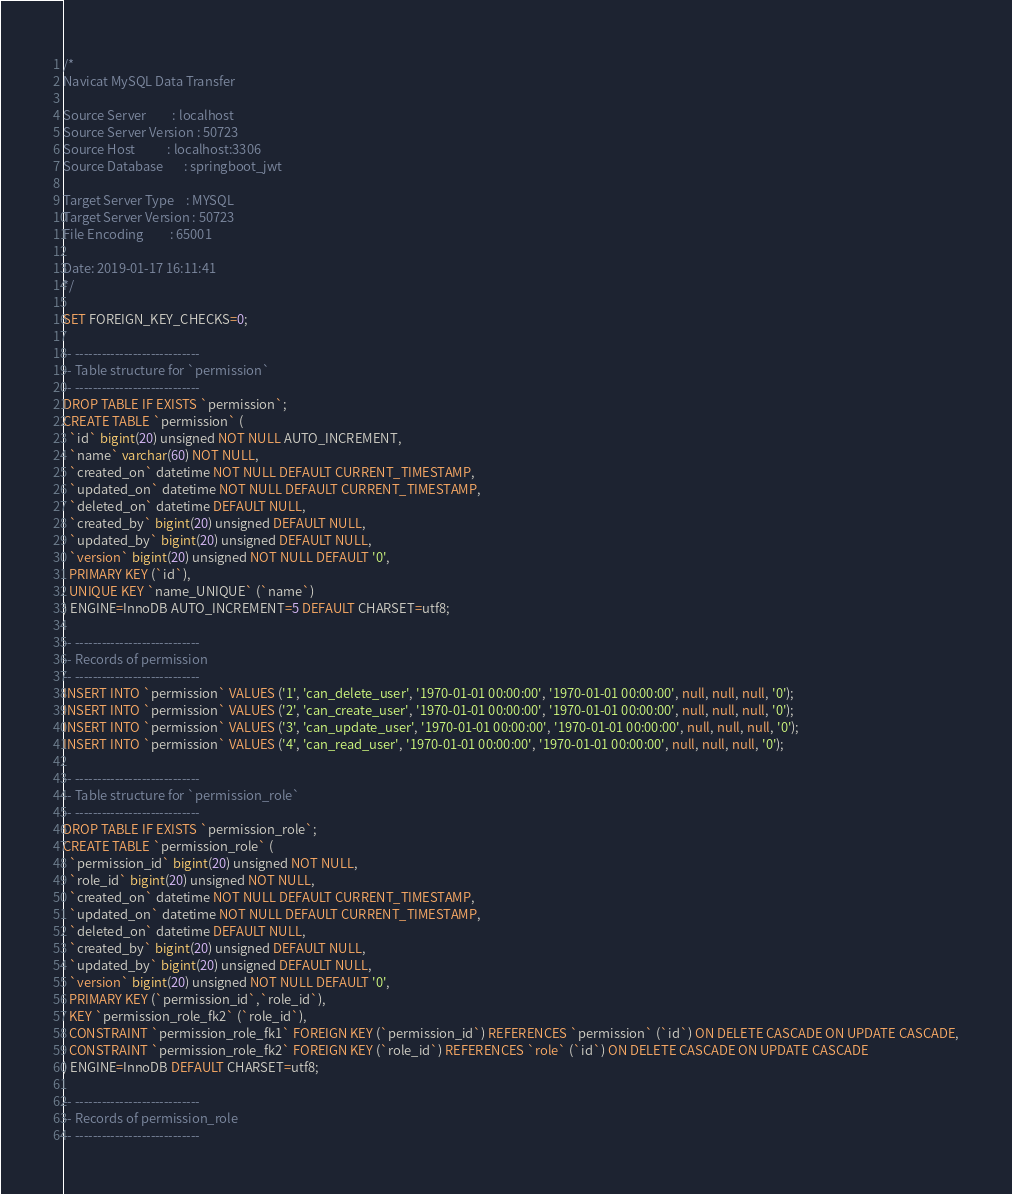Convert code to text. <code><loc_0><loc_0><loc_500><loc_500><_SQL_>/*
Navicat MySQL Data Transfer

Source Server         : localhost
Source Server Version : 50723
Source Host           : localhost:3306
Source Database       : springboot_jwt

Target Server Type    : MYSQL
Target Server Version : 50723
File Encoding         : 65001

Date: 2019-01-17 16:11:41
*/

SET FOREIGN_KEY_CHECKS=0;

-- ----------------------------
-- Table structure for `permission`
-- ----------------------------
DROP TABLE IF EXISTS `permission`;
CREATE TABLE `permission` (
  `id` bigint(20) unsigned NOT NULL AUTO_INCREMENT,
  `name` varchar(60) NOT NULL,
  `created_on` datetime NOT NULL DEFAULT CURRENT_TIMESTAMP,
  `updated_on` datetime NOT NULL DEFAULT CURRENT_TIMESTAMP,
  `deleted_on` datetime DEFAULT NULL,
  `created_by` bigint(20) unsigned DEFAULT NULL,
  `updated_by` bigint(20) unsigned DEFAULT NULL,
  `version` bigint(20) unsigned NOT NULL DEFAULT '0',
  PRIMARY KEY (`id`),
  UNIQUE KEY `name_UNIQUE` (`name`)
) ENGINE=InnoDB AUTO_INCREMENT=5 DEFAULT CHARSET=utf8;

-- ----------------------------
-- Records of permission
-- ----------------------------
INSERT INTO `permission` VALUES ('1', 'can_delete_user', '1970-01-01 00:00:00', '1970-01-01 00:00:00', null, null, null, '0');
INSERT INTO `permission` VALUES ('2', 'can_create_user', '1970-01-01 00:00:00', '1970-01-01 00:00:00', null, null, null, '0');
INSERT INTO `permission` VALUES ('3', 'can_update_user', '1970-01-01 00:00:00', '1970-01-01 00:00:00', null, null, null, '0');
INSERT INTO `permission` VALUES ('4', 'can_read_user', '1970-01-01 00:00:00', '1970-01-01 00:00:00', null, null, null, '0');

-- ----------------------------
-- Table structure for `permission_role`
-- ----------------------------
DROP TABLE IF EXISTS `permission_role`;
CREATE TABLE `permission_role` (
  `permission_id` bigint(20) unsigned NOT NULL,
  `role_id` bigint(20) unsigned NOT NULL,
  `created_on` datetime NOT NULL DEFAULT CURRENT_TIMESTAMP,
  `updated_on` datetime NOT NULL DEFAULT CURRENT_TIMESTAMP,
  `deleted_on` datetime DEFAULT NULL,
  `created_by` bigint(20) unsigned DEFAULT NULL,
  `updated_by` bigint(20) unsigned DEFAULT NULL,
  `version` bigint(20) unsigned NOT NULL DEFAULT '0',
  PRIMARY KEY (`permission_id`,`role_id`),
  KEY `permission_role_fk2` (`role_id`),
  CONSTRAINT `permission_role_fk1` FOREIGN KEY (`permission_id`) REFERENCES `permission` (`id`) ON DELETE CASCADE ON UPDATE CASCADE,
  CONSTRAINT `permission_role_fk2` FOREIGN KEY (`role_id`) REFERENCES `role` (`id`) ON DELETE CASCADE ON UPDATE CASCADE
) ENGINE=InnoDB DEFAULT CHARSET=utf8;

-- ----------------------------
-- Records of permission_role
-- ----------------------------</code> 